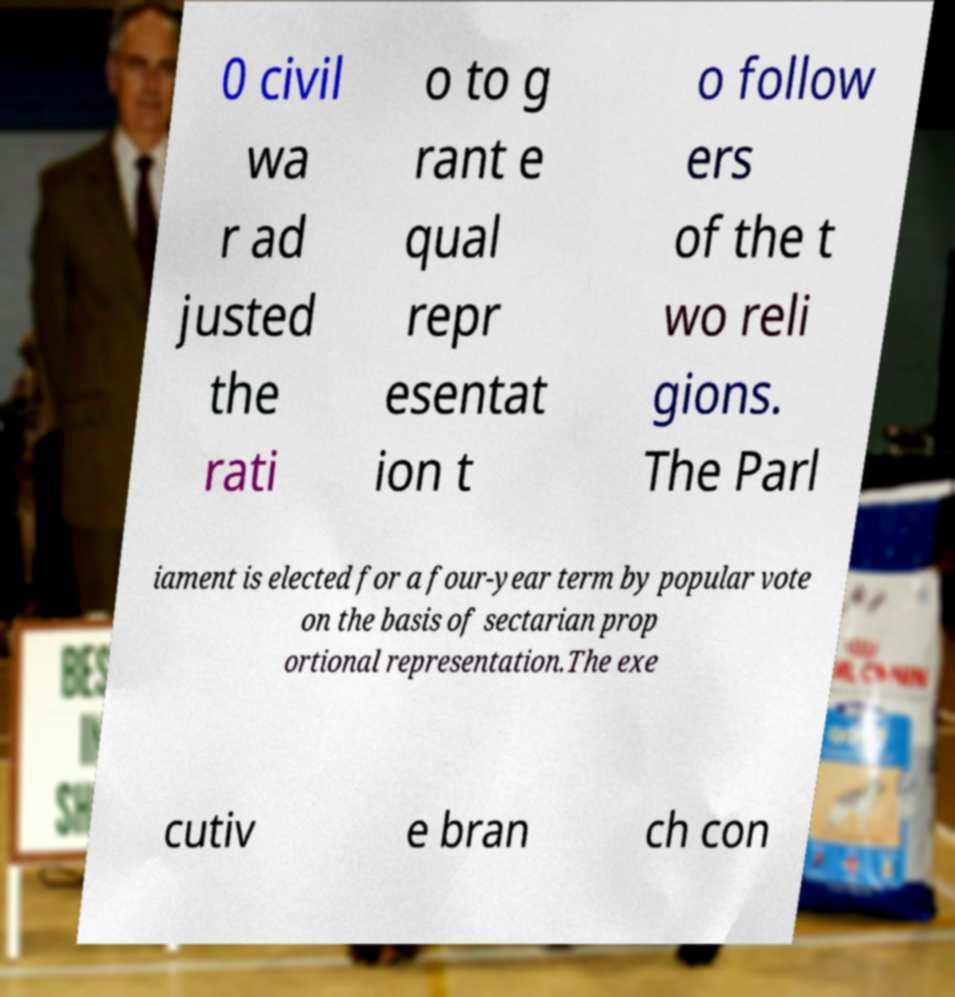Please read and relay the text visible in this image. What does it say? 0 civil wa r ad justed the rati o to g rant e qual repr esentat ion t o follow ers of the t wo reli gions. The Parl iament is elected for a four-year term by popular vote on the basis of sectarian prop ortional representation.The exe cutiv e bran ch con 